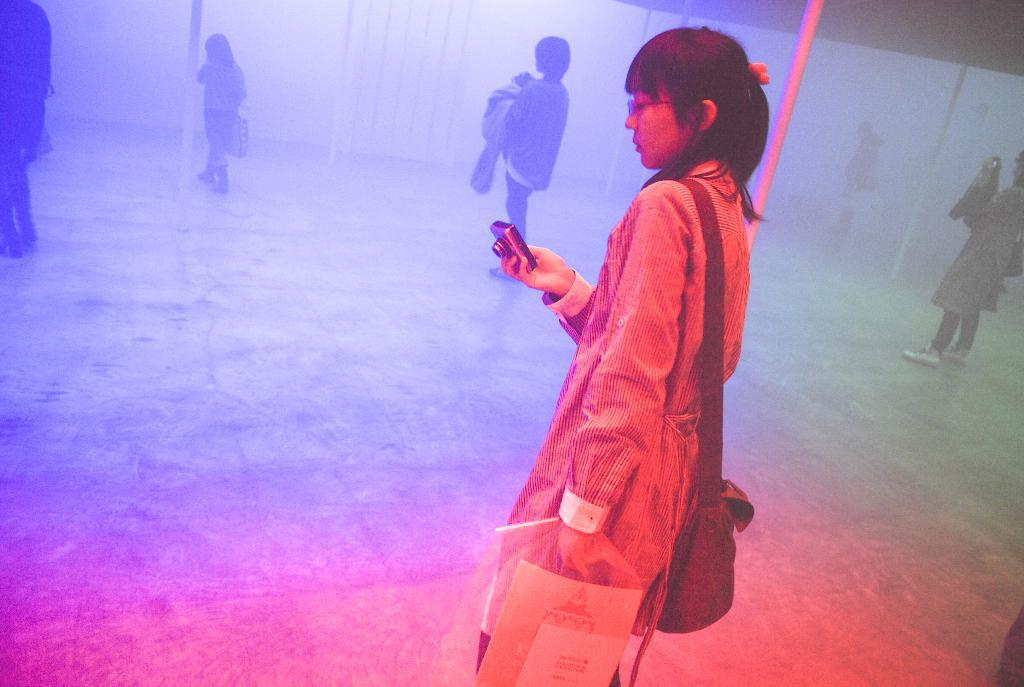Who is the main subject in the picture? There is a woman in the picture. Where is the woman positioned in the image? The woman is standing in the middle of the picture. What is the woman holding in her hand? The woman is holding a camera in her hand. What can be seen in the background of the picture? There are people in the background of the picture. What are the people in the background doing? The people are walking on the floor. What type of pen can be seen in the woman's hand in the image? There is no pen visible in the woman's hand in the image; she is holding a camera. 